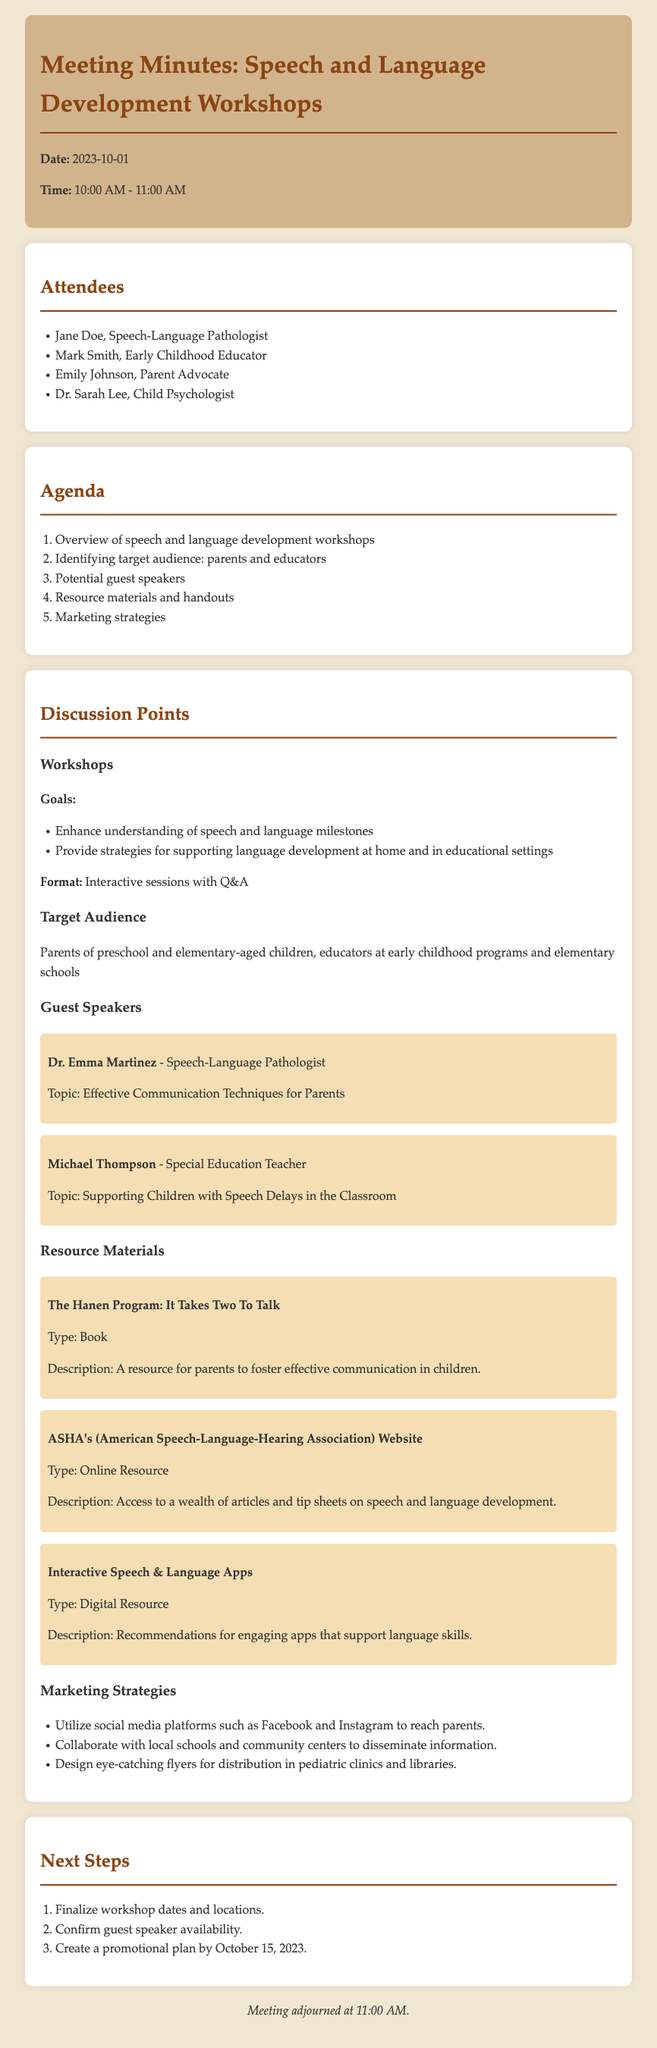what is the date of the meeting? The date of the meeting is mentioned at the top of the document.
Answer: 2023-10-01 who is a guest speaker discussing effective communication techniques? The document lists guest speakers along with topics they will discuss.
Answer: Dr. Emma Martinez what is the target audience for the workshops? The target audience is specified under the "Target Audience" section.
Answer: Parents and educators how many attendees were present at the meeting? The number of attendees can be counted from the list in the document.
Answer: 4 what is one resource material mentioned? Resource materials are listed in the document, along with their types and descriptions.
Answer: The Hanen Program: It Takes Two To Talk what is the total number of agenda items? The agenda section lists items that can be counted to determine the total.
Answer: 5 what strategy is recommended for marketing the workshops? The document includes a section on marketing strategies with specific recommendations.
Answer: Utilize social media platforms what is the format of the workshops? The format is discussed under the "Workshops" section of the meeting minutes.
Answer: Interactive sessions with Q&A when is the promotional plan due? The deadline for the promotional plan is mentioned in the "Next Steps" section.
Answer: October 15, 2023 